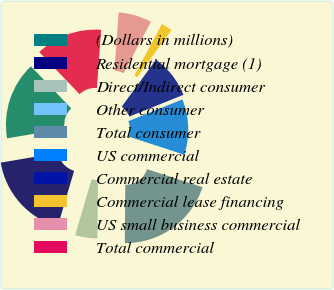Convert chart to OTSL. <chart><loc_0><loc_0><loc_500><loc_500><pie_chart><fcel>(Dollars in millions)<fcel>Residential mortgage (1)<fcel>Direct/Indirect consumer<fcel>Other consumer<fcel>Total consumer<fcel>US commercial<fcel>Commercial real estate<fcel>Commercial lease financing<fcel>US small business commercial<fcel>Total commercial<nl><fcel>15.53%<fcel>17.75%<fcel>4.44%<fcel>0.0%<fcel>20.12%<fcel>11.09%<fcel>8.88%<fcel>2.22%<fcel>6.66%<fcel>13.31%<nl></chart> 